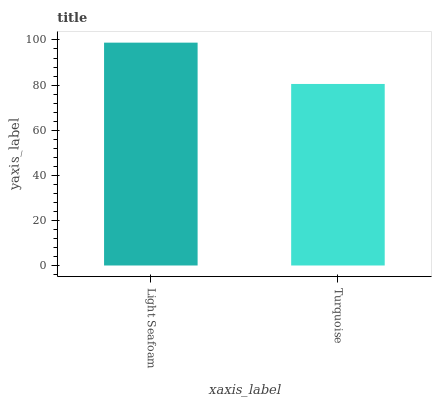Is Turquoise the maximum?
Answer yes or no. No. Is Light Seafoam greater than Turquoise?
Answer yes or no. Yes. Is Turquoise less than Light Seafoam?
Answer yes or no. Yes. Is Turquoise greater than Light Seafoam?
Answer yes or no. No. Is Light Seafoam less than Turquoise?
Answer yes or no. No. Is Light Seafoam the high median?
Answer yes or no. Yes. Is Turquoise the low median?
Answer yes or no. Yes. Is Turquoise the high median?
Answer yes or no. No. Is Light Seafoam the low median?
Answer yes or no. No. 